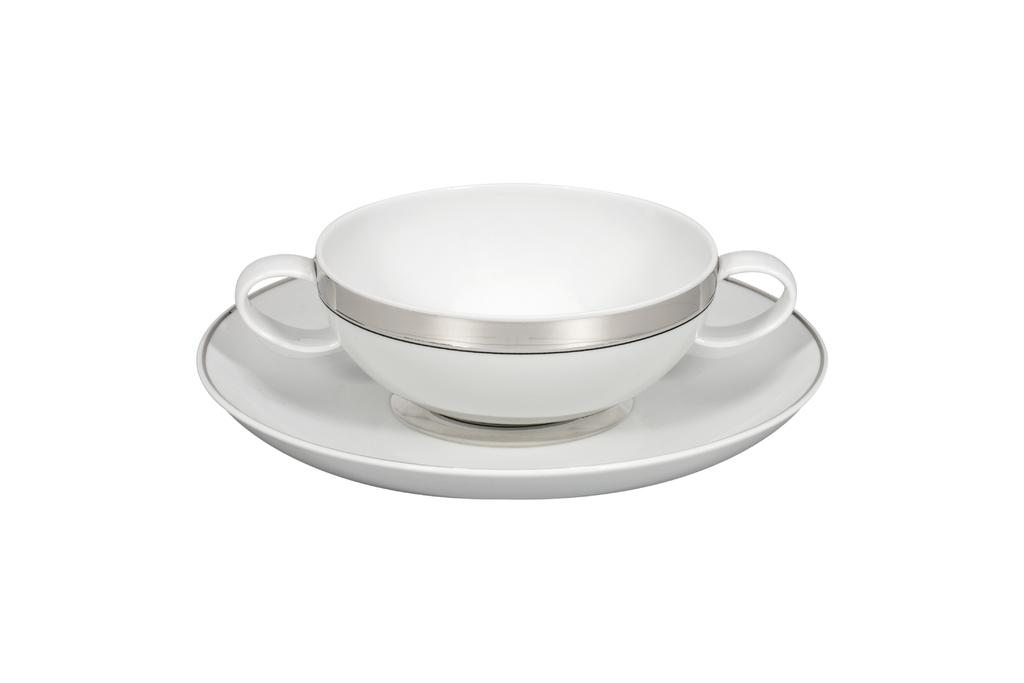What is located in the center of the image? There is a cup and a saucer in the center of the image. Can you describe the cup in the image? The cup is in the center of the image. What is the saucer used for in the image? The saucer is in the center of the image and is typically used to hold a cup. How many balls are visible in the image? There are no balls present in the image. What type of glass is used to make the cup in the image? The image does not provide information about the material used to make the cup, so it cannot be determined from the image. 